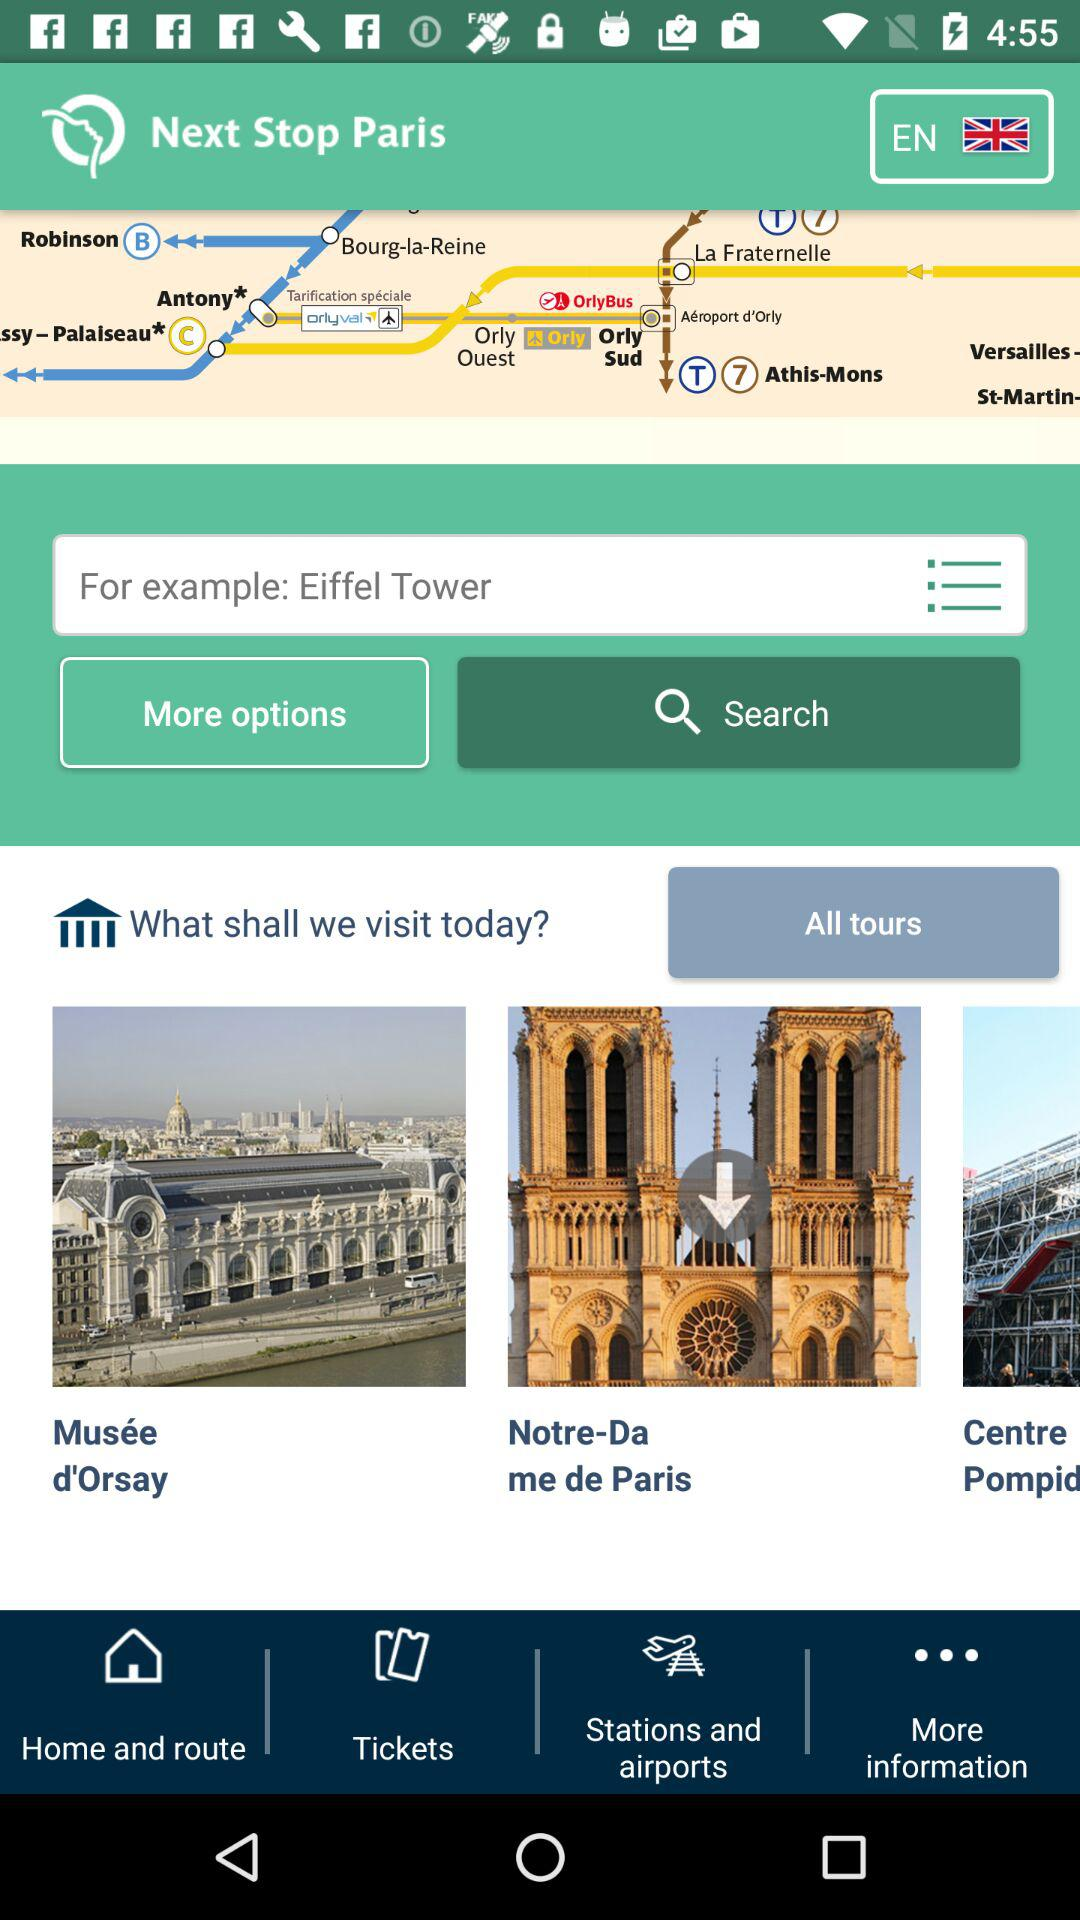What language is selected? The selected language is English. 